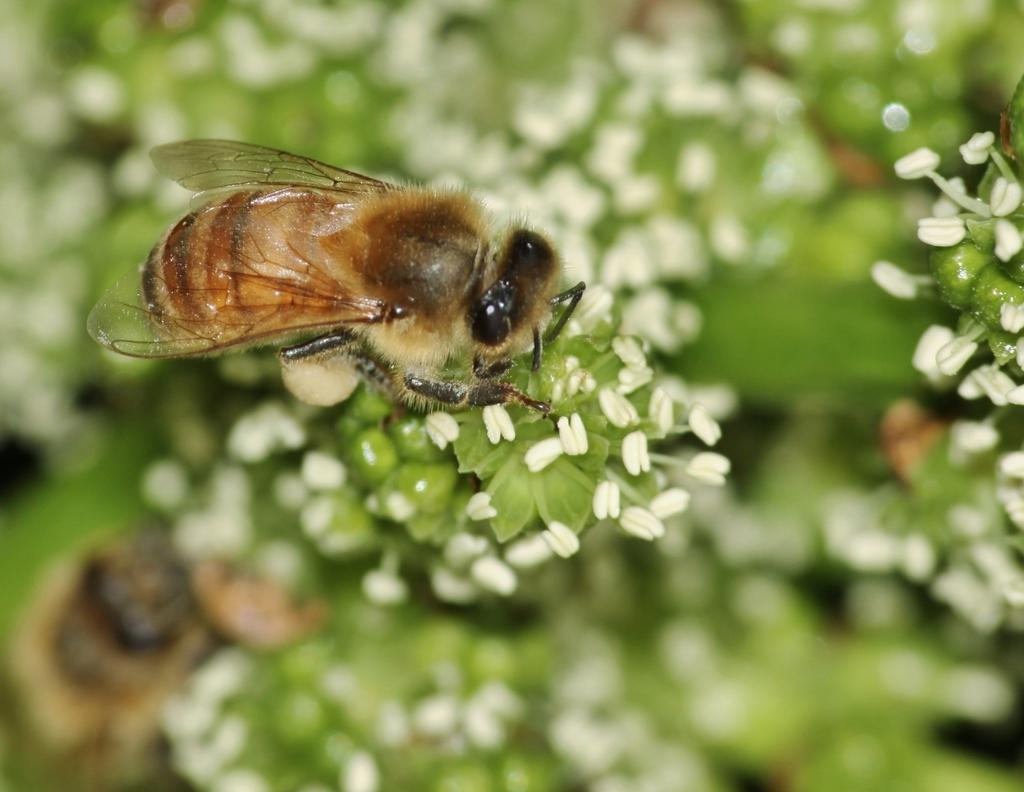What type of living organisms can be seen in the image? Insects can be seen in the image. What stage of growth are the plants in the image? The plants in the image have buds. How would you describe the background of the image? The background of the image is blurred. What type of mask is being worn by the fowl in the image? There is no fowl or mask present in the image. How does the ray of light affect the insects in the image? There is no mention of a ray of light in the image, so its effect on the insects cannot be determined. 